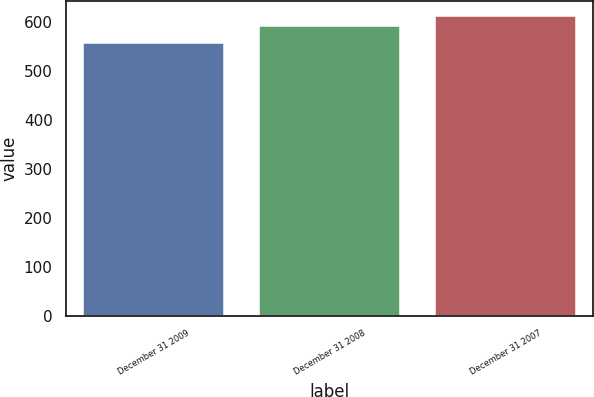<chart> <loc_0><loc_0><loc_500><loc_500><bar_chart><fcel>December 31 2009<fcel>December 31 2008<fcel>December 31 2007<nl><fcel>557.3<fcel>591.7<fcel>611.7<nl></chart> 